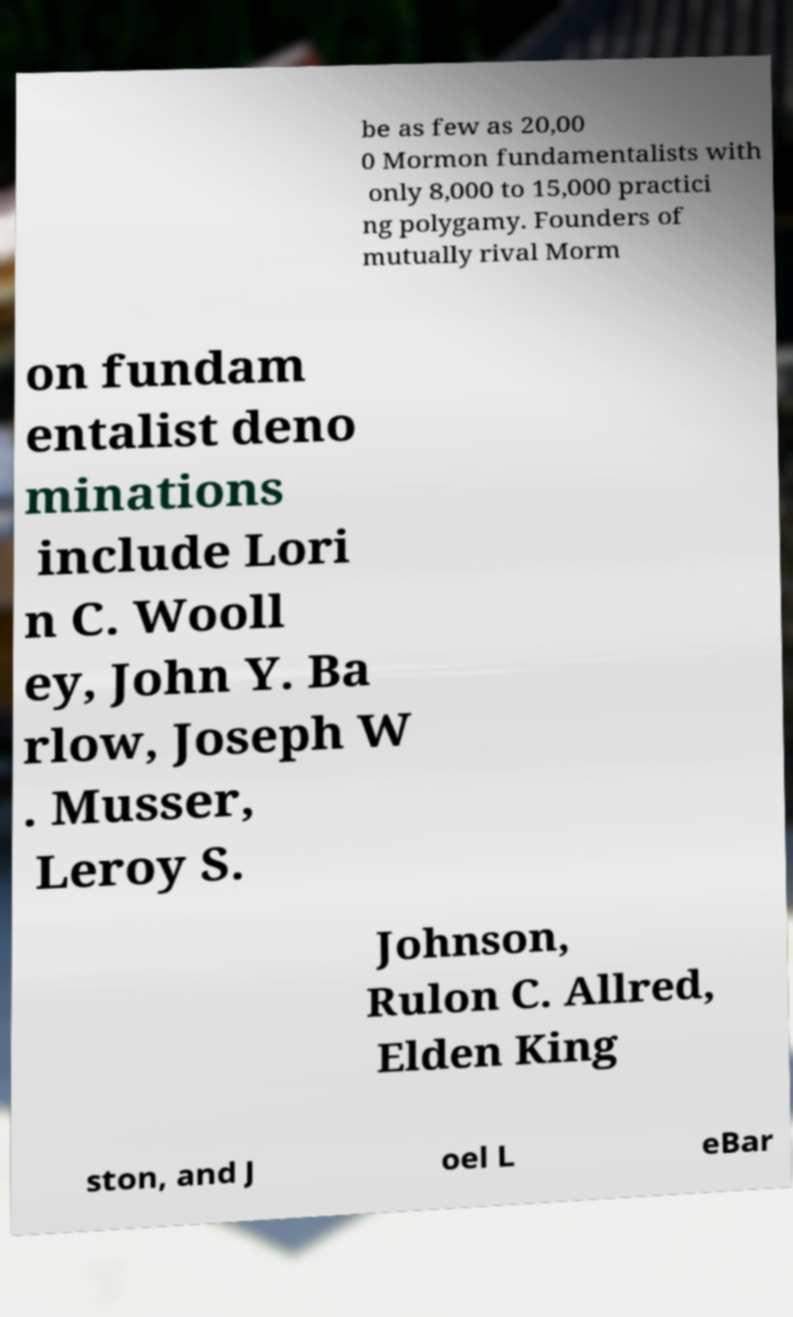What messages or text are displayed in this image? I need them in a readable, typed format. be as few as 20,00 0 Mormon fundamentalists with only 8,000 to 15,000 practici ng polygamy. Founders of mutually rival Morm on fundam entalist deno minations include Lori n C. Wooll ey, John Y. Ba rlow, Joseph W . Musser, Leroy S. Johnson, Rulon C. Allred, Elden King ston, and J oel L eBar 